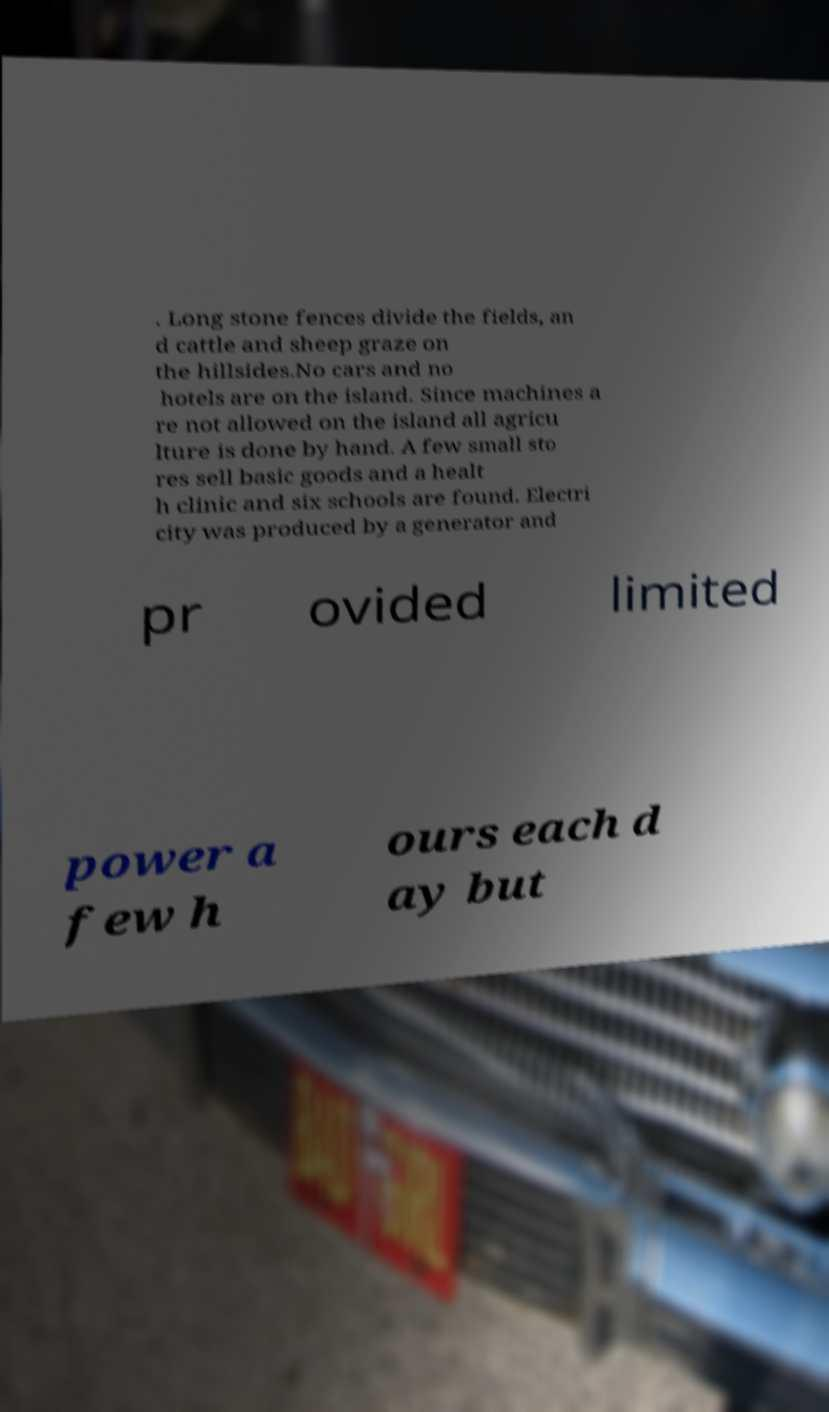For documentation purposes, I need the text within this image transcribed. Could you provide that? . Long stone fences divide the fields, an d cattle and sheep graze on the hillsides.No cars and no hotels are on the island. Since machines a re not allowed on the island all agricu lture is done by hand. A few small sto res sell basic goods and a healt h clinic and six schools are found. Electri city was produced by a generator and pr ovided limited power a few h ours each d ay but 